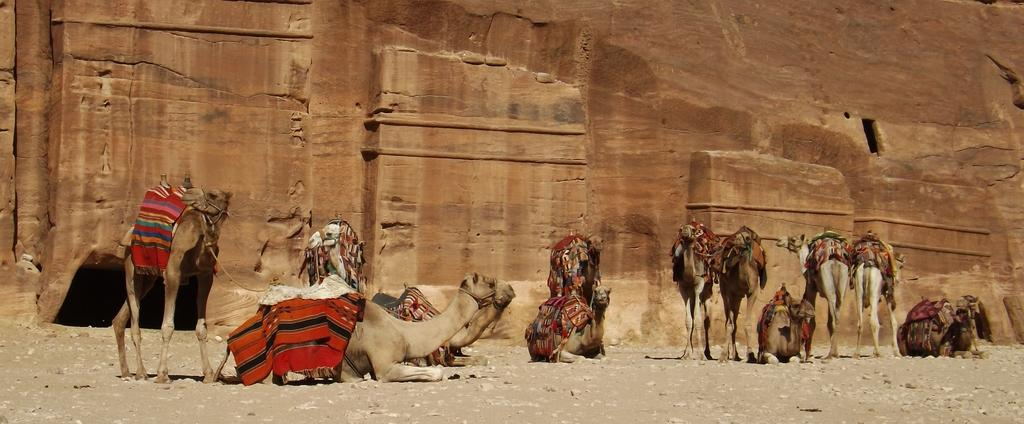What animals are present in the image? There are camels in the image. What can be seen in the background of the image? There is a rocky mountain in the background of the image. Who is the owner of the camera in the image? There is no camera present in the image, so it is not possible to determine the owner. 